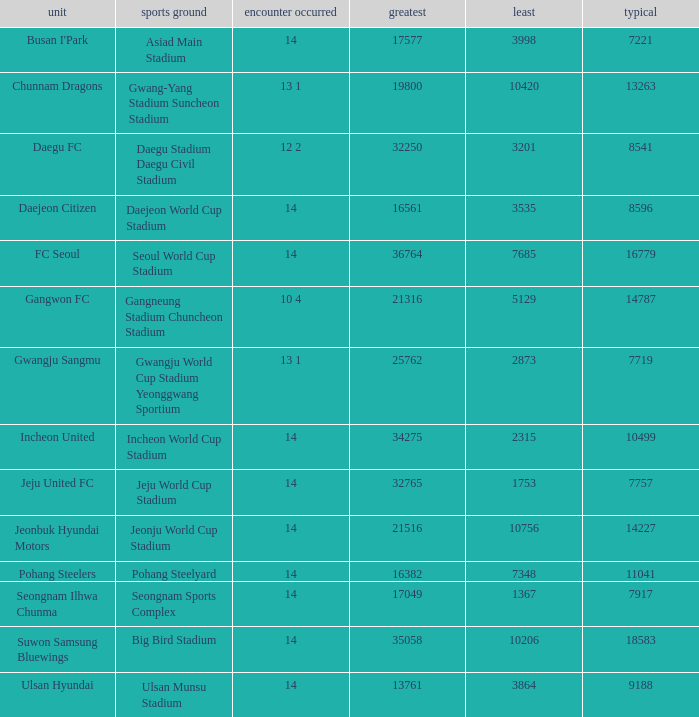What is the lowest when pohang steelyard is the stadium? 7348.0. 